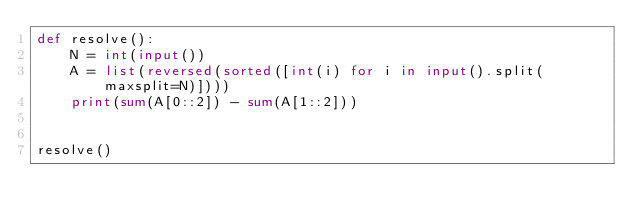Convert code to text. <code><loc_0><loc_0><loc_500><loc_500><_Python_>def resolve():
    N = int(input())
    A = list(reversed(sorted([int(i) for i in input().split(maxsplit=N)])))
    print(sum(A[0::2]) - sum(A[1::2]))


resolve()
</code> 